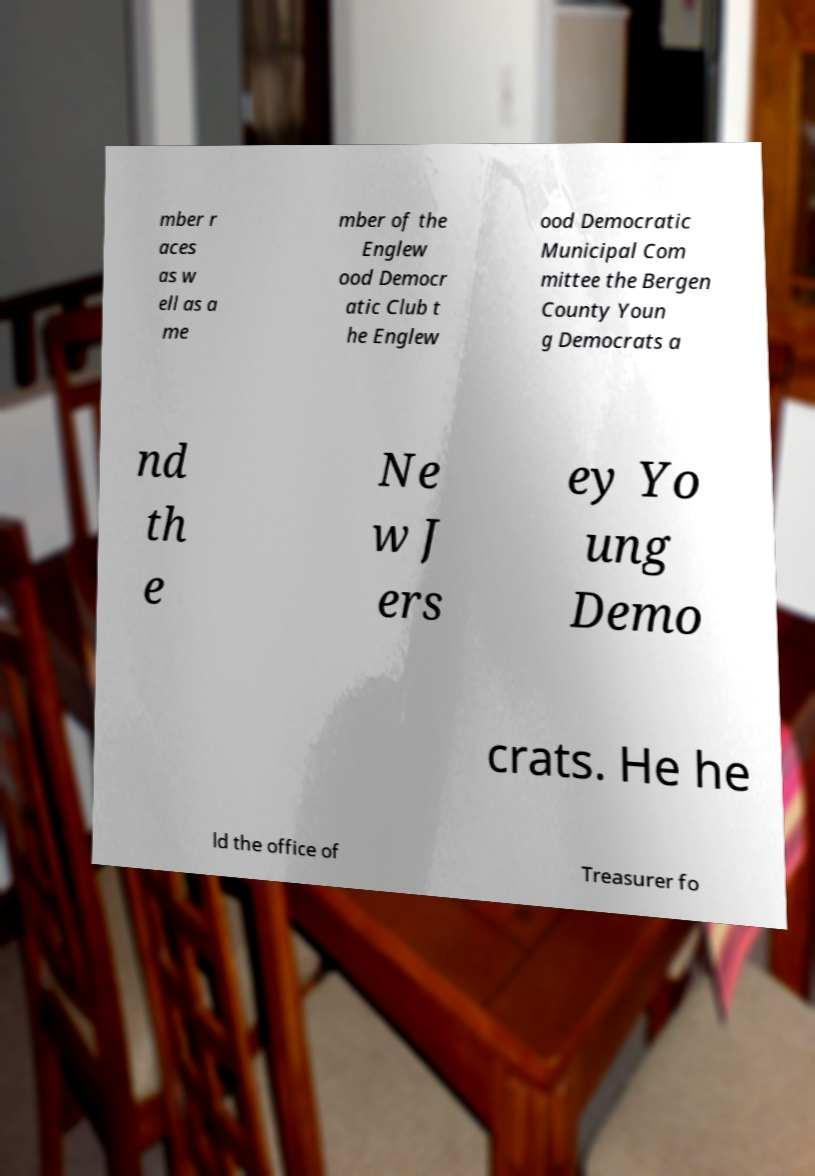Please identify and transcribe the text found in this image. mber r aces as w ell as a me mber of the Englew ood Democr atic Club t he Englew ood Democratic Municipal Com mittee the Bergen County Youn g Democrats a nd th e Ne w J ers ey Yo ung Demo crats. He he ld the office of Treasurer fo 